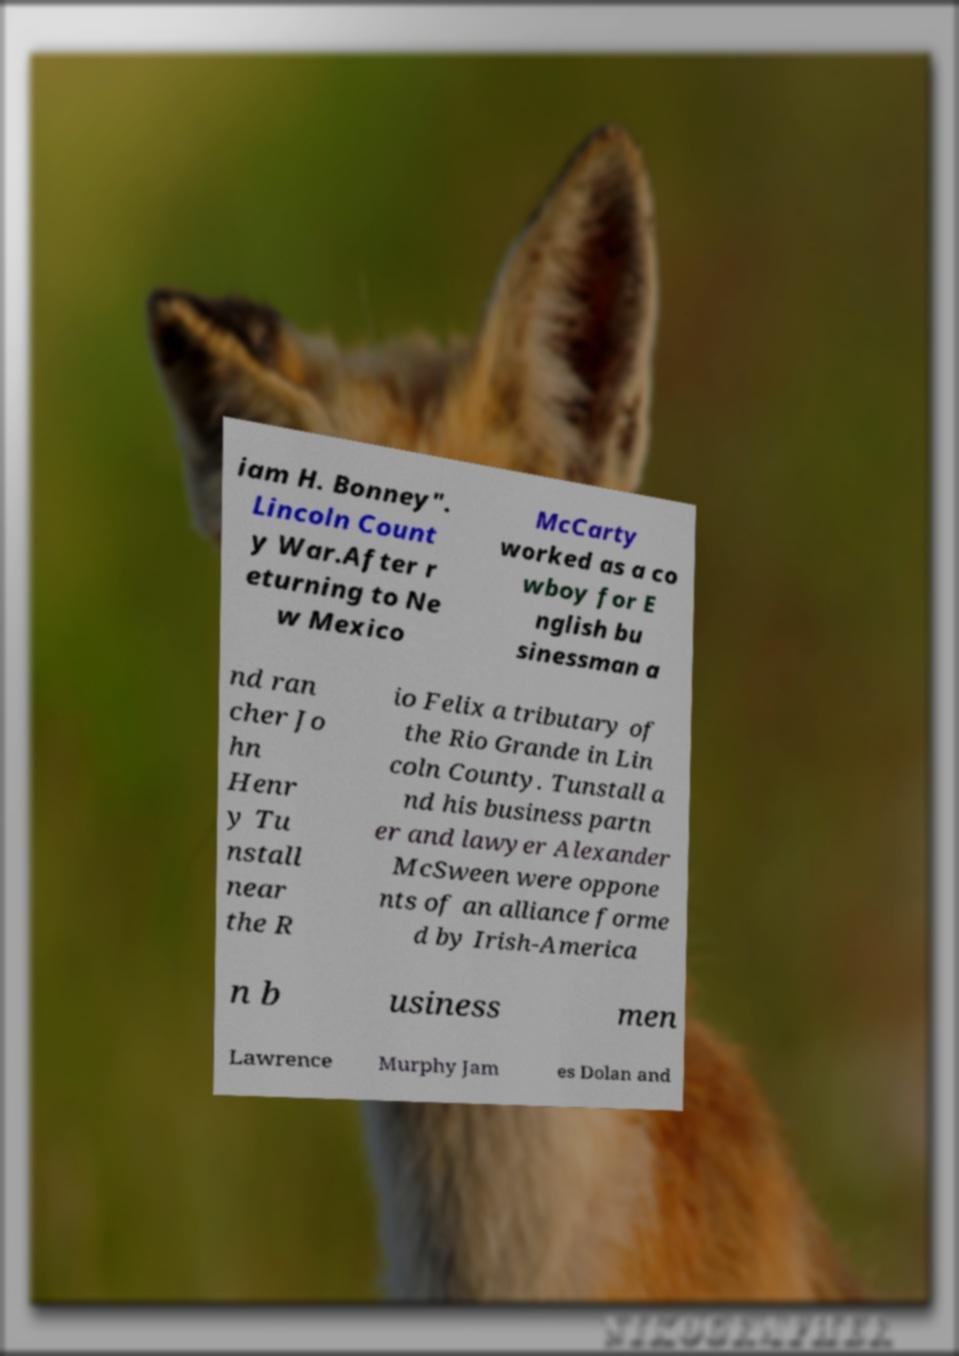What messages or text are displayed in this image? I need them in a readable, typed format. iam H. Bonney". Lincoln Count y War.After r eturning to Ne w Mexico McCarty worked as a co wboy for E nglish bu sinessman a nd ran cher Jo hn Henr y Tu nstall near the R io Felix a tributary of the Rio Grande in Lin coln County. Tunstall a nd his business partn er and lawyer Alexander McSween were oppone nts of an alliance forme d by Irish-America n b usiness men Lawrence Murphy Jam es Dolan and 